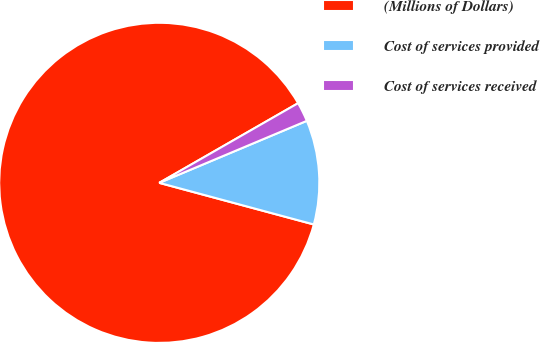Convert chart to OTSL. <chart><loc_0><loc_0><loc_500><loc_500><pie_chart><fcel>(Millions of Dollars)<fcel>Cost of services provided<fcel>Cost of services received<nl><fcel>87.52%<fcel>10.52%<fcel>1.96%<nl></chart> 